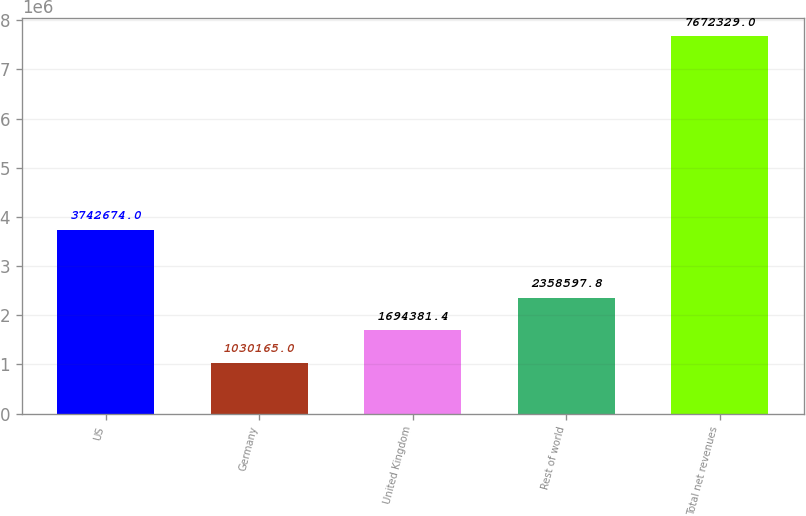<chart> <loc_0><loc_0><loc_500><loc_500><bar_chart><fcel>US<fcel>Germany<fcel>United Kingdom<fcel>Rest of world<fcel>Total net revenues<nl><fcel>3.74267e+06<fcel>1.03016e+06<fcel>1.69438e+06<fcel>2.3586e+06<fcel>7.67233e+06<nl></chart> 